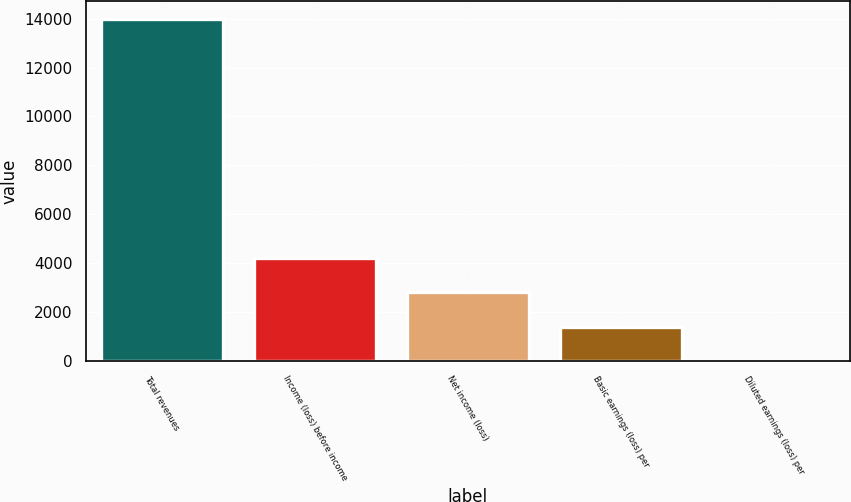<chart> <loc_0><loc_0><loc_500><loc_500><bar_chart><fcel>Total revenues<fcel>Income (loss) before income<fcel>Net income (loss)<fcel>Basic earnings (loss) per<fcel>Diluted earnings (loss) per<nl><fcel>14007<fcel>4203.53<fcel>2803.04<fcel>1402.55<fcel>2.06<nl></chart> 